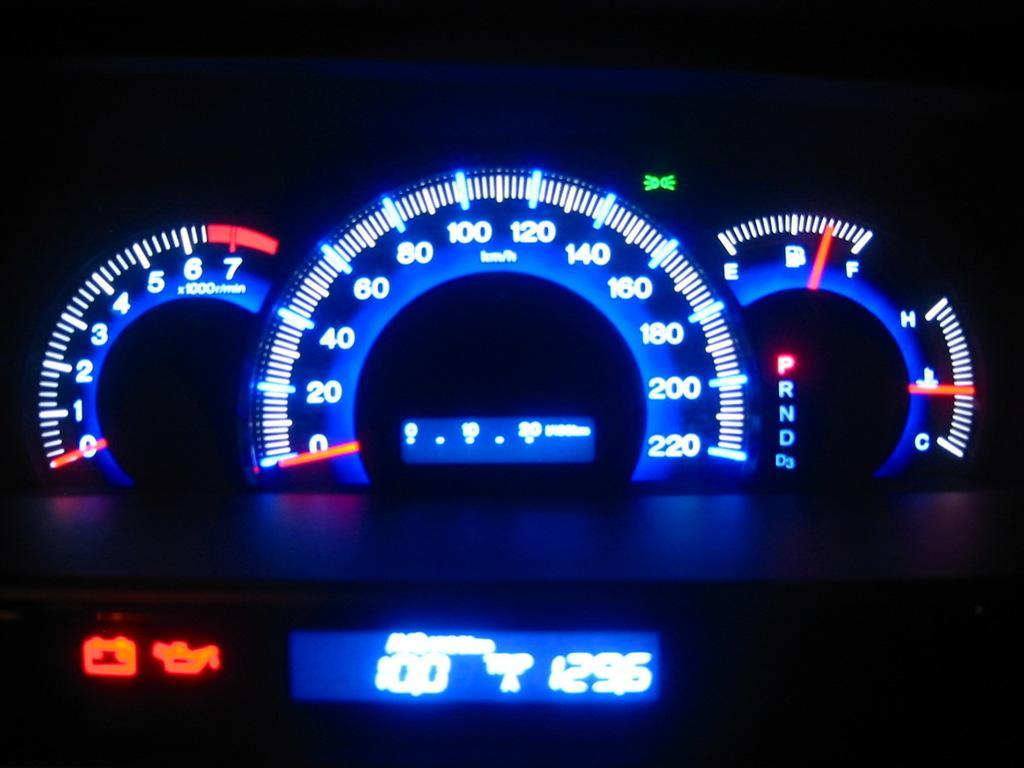How would you summarize this image in a sentence or two? In this picture I can see there is a speedometer and it has indicators and numbers. There is a small display screen and there are two symbols on the left side of the screen and the rest of the image is dark. 